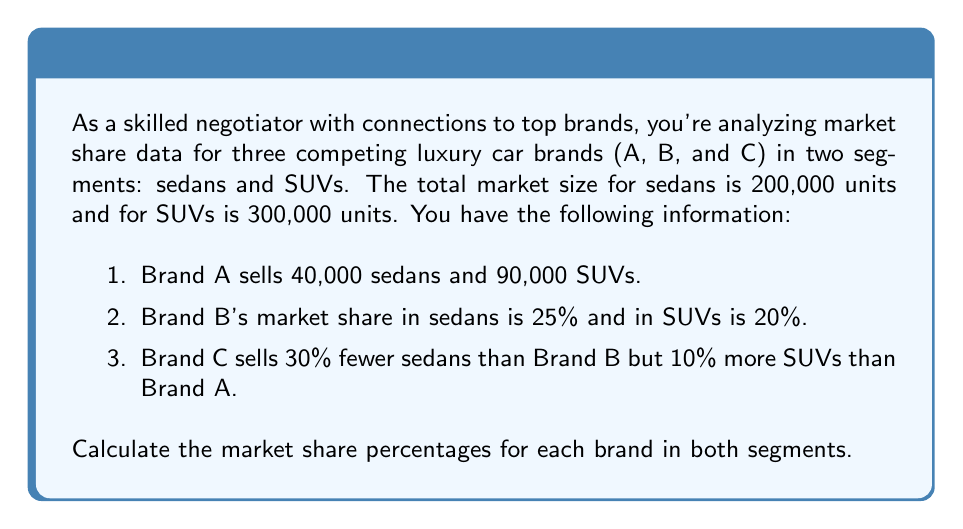Could you help me with this problem? Let's solve this problem step by step:

1. Calculate Brand B's sales:
   Sedans: $0.25 \times 200,000 = 50,000$ units
   SUVs: $0.20 \times 300,000 = 60,000$ units

2. Calculate Brand C's sales:
   Sedans: $50,000 \times 0.7 = 35,000$ units (30% fewer than Brand B)
   SUVs: $90,000 \times 1.1 = 99,000$ units (10% more than Brand A)

3. Calculate market share percentages for each brand in both segments:

   Sedan segment:
   Brand A: $\frac{40,000}{200,000} \times 100\% = 20\%$
   Brand B: $\frac{50,000}{200,000} \times 100\% = 25\%$
   Brand C: $\frac{35,000}{200,000} \times 100\% = 17.5\%$

   SUV segment:
   Brand A: $\frac{90,000}{300,000} \times 100\% = 30\%$
   Brand B: $\frac{60,000}{300,000} \times 100\% = 20\%$
   Brand C: $\frac{99,000}{300,000} \times 100\% = 33\%$

4. Verify that the percentages sum to 100% in each segment:
   Sedans: $20\% + 25\% + 17.5\% = 62.5\%$
   SUVs: $30\% + 20\% + 33\% = 83\%$

   Note: The percentages don't sum to 100% because there are other brands in the market not mentioned in the problem.
Answer: Market share percentages:

Sedan segment:
Brand A: 20%
Brand B: 25%
Brand C: 17.5%

SUV segment:
Brand A: 30%
Brand B: 20%
Brand C: 33% 